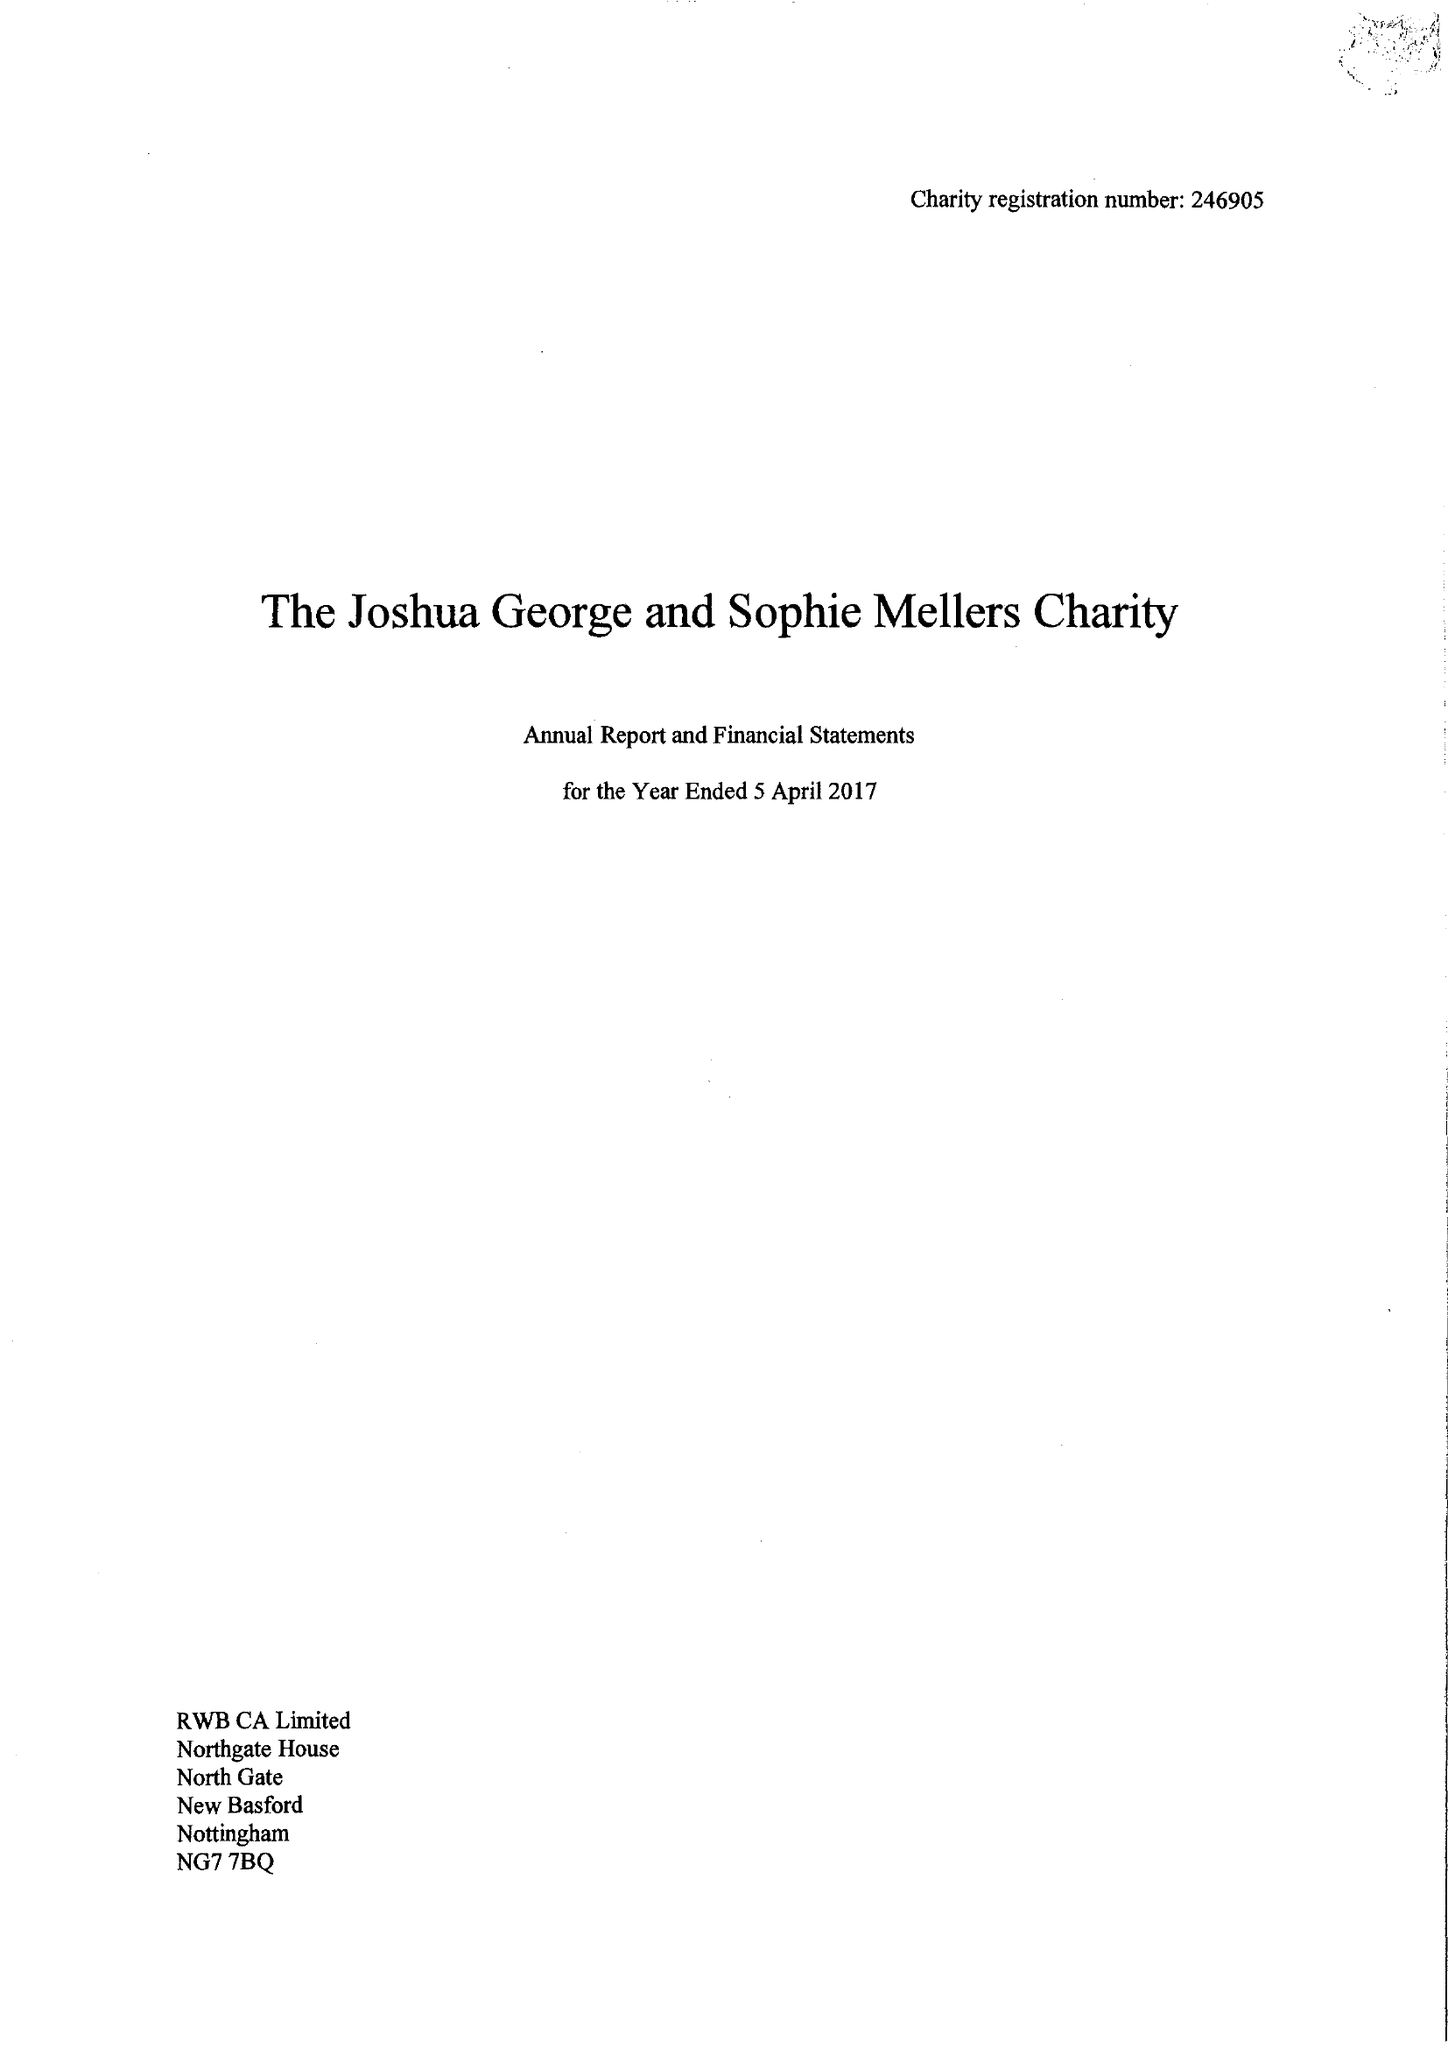What is the value for the spending_annually_in_british_pounds?
Answer the question using a single word or phrase. 40440.00 